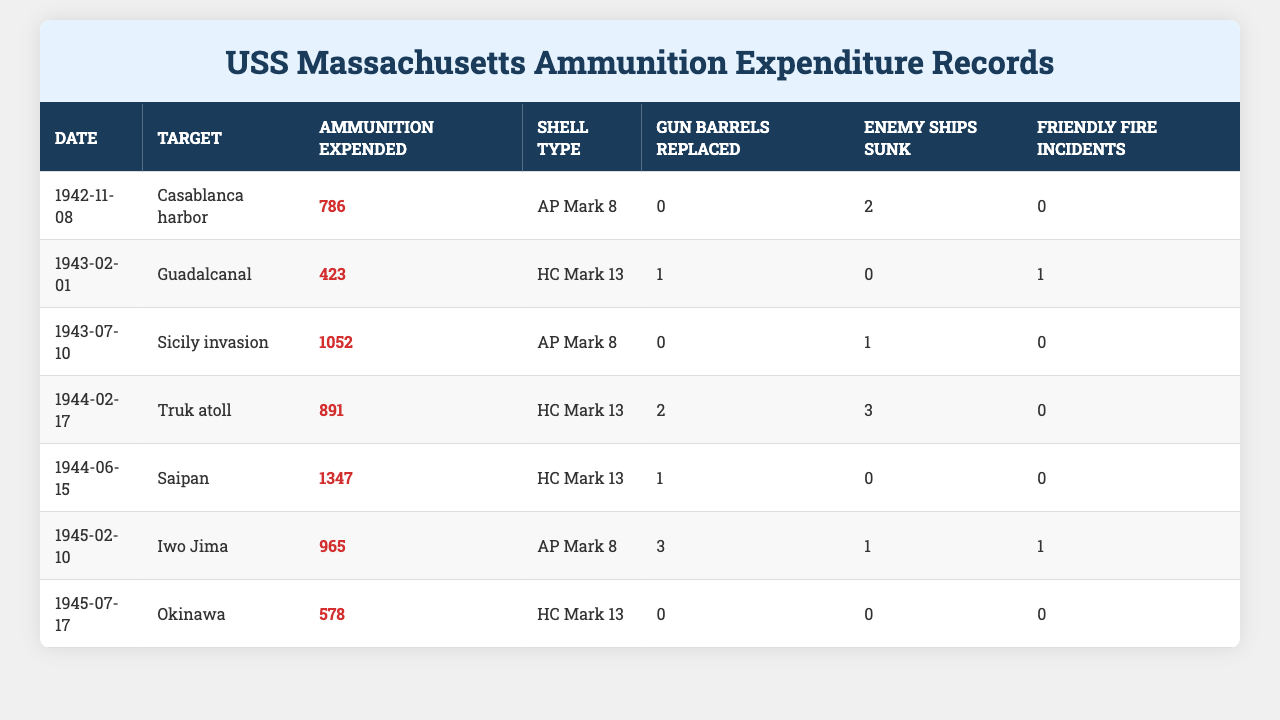What date was the highest ammunition expenditure recorded? To find the date with the highest ammunition expenditure, we look through the "Ammunition Expended" column, which shows values of 786, 423, 1052, 891, 1347, 965, and 578. The highest value is 1347, which corresponds to the date "1944-06-15".
Answer: 1944-06-15 How many enemy ships were sunk during the operation on July 10, 1943? Referring to the data for the date "1943-07-10", we check the "Enemy Ships Sunk" column, which shows a value of 1 for that date.
Answer: 1 What type of shell was used on February 17, 1944? We can look directly at the row corresponding to the date "1944-02-17" in the "Shell Type" column. It shows "HC Mark 13".
Answer: HC Mark 13 How many total gun barrels were replaced throughout the recorded operations? To find the total number of gun barrels replaced, we sum up the values in the "Gun Barrels Replaced" column, which are 0, 1, 0, 2, 1, 3, and 0. Adding these gives us 0 + 1 + 0 + 2 + 1 + 3 + 0 = 7.
Answer: 7 What was the average ammunition expended across all recorded dates? We calculate the average by first summing the "Ammunition Expended" values: 786 + 423 + 1052 + 891 + 1347 + 965 + 578 = 5042. Since there are 7 data points, we divide the total by 7, so 5042 / 7 = 720.2857, rounded off is 720.
Answer: 720 Was there any friendly fire incident recorded during the operation on February 10, 1945? Looking at the record for the date "1945-02-10" in the "Friendly Fire Incidents" column, we see a value of 1, which indicates that a friendly fire incident did occur.
Answer: Yes Which operation resulted in the most enemy ships sunk? We examine the "Enemy Ships Sunk" column for all operations: 2, 0, 1, 3, 0, 1, 0. The highest number is 3, which corresponds to the operation on "1944-02-17" at Truk atoll.
Answer: Truk atoll On which operation did the USS Massachusetts expend more than 1000 rounds of ammunition? We check the "Ammunition Expended" column for values over 1000. The only entry exceeding that threshold is 1052 on "1943-07-10".
Answer: Sicily invasion How many operations resulted in friendly fire incidents? We count the occurrences of 1 in the "Friendly Fire Incidents" column: 0, 1, 0, 0, 0, 1, 0, leading to a total of 2 incidents.
Answer: 2 Was the ammunition expenditure higher on June 15, 1944, than on February 10, 1945? Comparing the values from the "Ammunition Expended" column for those dates, we have 1347 for June 15, 1944, and 965 for February 10, 1945. Since 1347 is greater than 965, the answer is yes.
Answer: Yes 